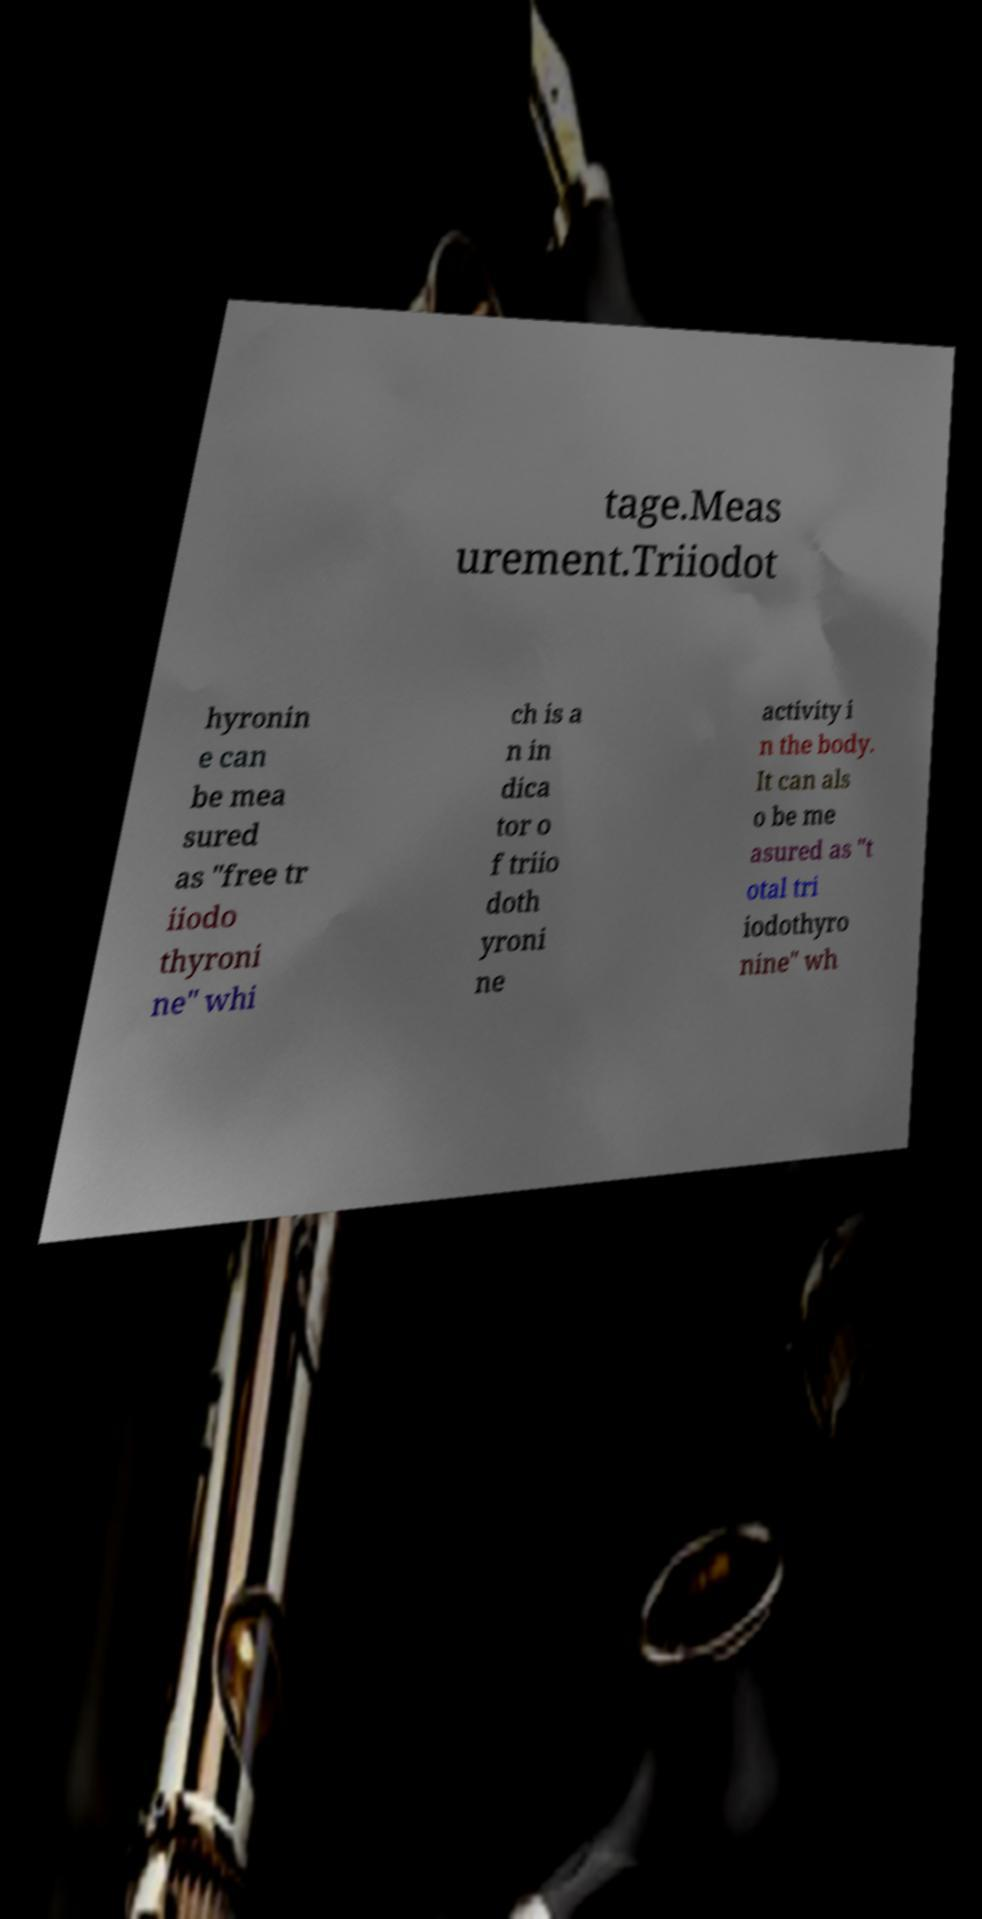I need the written content from this picture converted into text. Can you do that? tage.Meas urement.Triiodot hyronin e can be mea sured as "free tr iiodo thyroni ne" whi ch is a n in dica tor o f triio doth yroni ne activity i n the body. It can als o be me asured as "t otal tri iodothyro nine" wh 